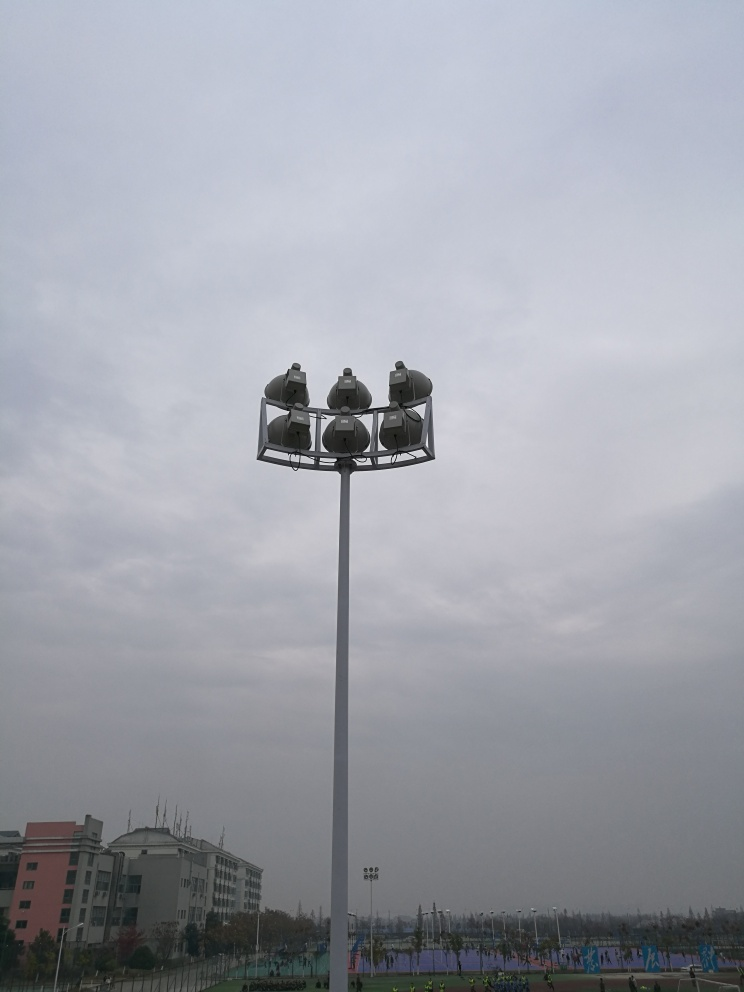Can you describe the weather conditions in the image? The sky is overcast, suggesting cloudy weather that could indicate an approaching weather system or simply diffused sunlight typical of certain times of the year or day. Do these weather conditions affect outdoor activities? While the cloud cover doesn't seem to be deterring the activities on the sports fields, certain outdoor events might be impacted depending on the potential for rain or reduced visibility. 